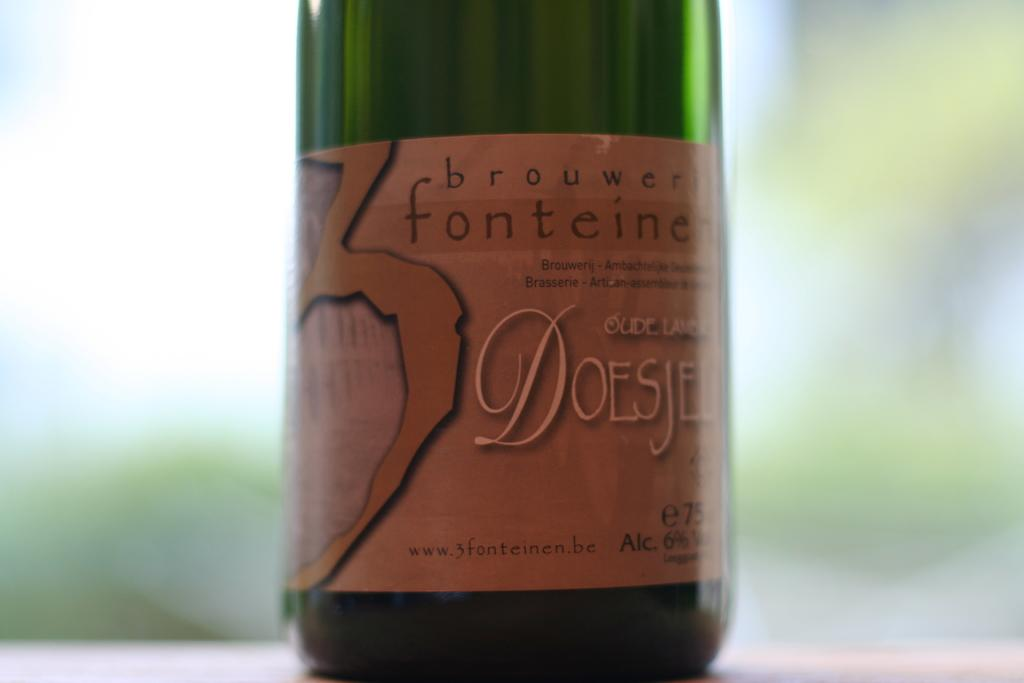<image>
Describe the image concisely. a close up of Fonteine wine in a green bottle on a table 